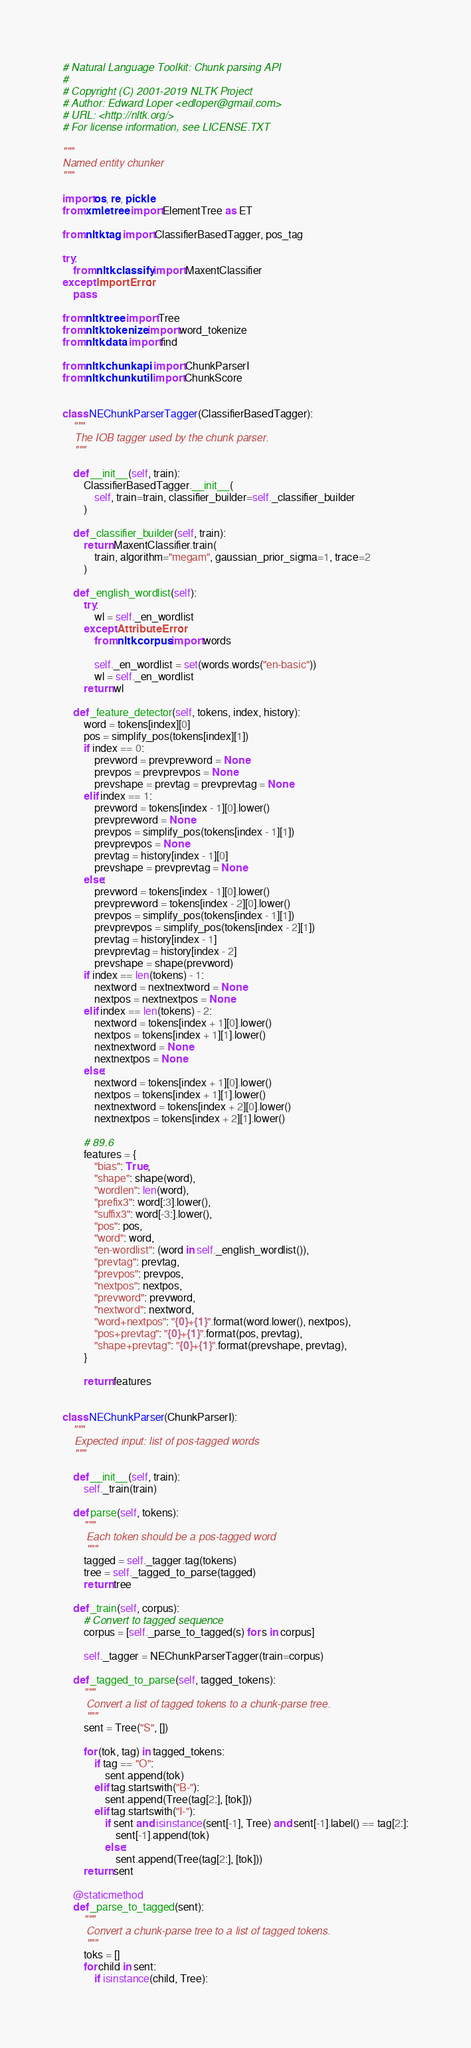<code> <loc_0><loc_0><loc_500><loc_500><_Python_># Natural Language Toolkit: Chunk parsing API
#
# Copyright (C) 2001-2019 NLTK Project
# Author: Edward Loper <edloper@gmail.com>
# URL: <http://nltk.org/>
# For license information, see LICENSE.TXT

"""
Named entity chunker
"""

import os, re, pickle
from xml.etree import ElementTree as ET

from nltk.tag import ClassifierBasedTagger, pos_tag

try:
    from nltk.classify import MaxentClassifier
except ImportError:
    pass

from nltk.tree import Tree
from nltk.tokenize import word_tokenize
from nltk.data import find

from nltk.chunk.api import ChunkParserI
from nltk.chunk.util import ChunkScore


class NEChunkParserTagger(ClassifierBasedTagger):
    """
    The IOB tagger used by the chunk parser.
    """

    def __init__(self, train):
        ClassifierBasedTagger.__init__(
            self, train=train, classifier_builder=self._classifier_builder
        )

    def _classifier_builder(self, train):
        return MaxentClassifier.train(
            train, algorithm="megam", gaussian_prior_sigma=1, trace=2
        )

    def _english_wordlist(self):
        try:
            wl = self._en_wordlist
        except AttributeError:
            from nltk.corpus import words

            self._en_wordlist = set(words.words("en-basic"))
            wl = self._en_wordlist
        return wl

    def _feature_detector(self, tokens, index, history):
        word = tokens[index][0]
        pos = simplify_pos(tokens[index][1])
        if index == 0:
            prevword = prevprevword = None
            prevpos = prevprevpos = None
            prevshape = prevtag = prevprevtag = None
        elif index == 1:
            prevword = tokens[index - 1][0].lower()
            prevprevword = None
            prevpos = simplify_pos(tokens[index - 1][1])
            prevprevpos = None
            prevtag = history[index - 1][0]
            prevshape = prevprevtag = None
        else:
            prevword = tokens[index - 1][0].lower()
            prevprevword = tokens[index - 2][0].lower()
            prevpos = simplify_pos(tokens[index - 1][1])
            prevprevpos = simplify_pos(tokens[index - 2][1])
            prevtag = history[index - 1]
            prevprevtag = history[index - 2]
            prevshape = shape(prevword)
        if index == len(tokens) - 1:
            nextword = nextnextword = None
            nextpos = nextnextpos = None
        elif index == len(tokens) - 2:
            nextword = tokens[index + 1][0].lower()
            nextpos = tokens[index + 1][1].lower()
            nextnextword = None
            nextnextpos = None
        else:
            nextword = tokens[index + 1][0].lower()
            nextpos = tokens[index + 1][1].lower()
            nextnextword = tokens[index + 2][0].lower()
            nextnextpos = tokens[index + 2][1].lower()

        # 89.6
        features = {
            "bias": True,
            "shape": shape(word),
            "wordlen": len(word),
            "prefix3": word[:3].lower(),
            "suffix3": word[-3:].lower(),
            "pos": pos,
            "word": word,
            "en-wordlist": (word in self._english_wordlist()),
            "prevtag": prevtag,
            "prevpos": prevpos,
            "nextpos": nextpos,
            "prevword": prevword,
            "nextword": nextword,
            "word+nextpos": "{0}+{1}".format(word.lower(), nextpos),
            "pos+prevtag": "{0}+{1}".format(pos, prevtag),
            "shape+prevtag": "{0}+{1}".format(prevshape, prevtag),
        }

        return features


class NEChunkParser(ChunkParserI):
    """
    Expected input: list of pos-tagged words
    """

    def __init__(self, train):
        self._train(train)

    def parse(self, tokens):
        """
        Each token should be a pos-tagged word
        """
        tagged = self._tagger.tag(tokens)
        tree = self._tagged_to_parse(tagged)
        return tree

    def _train(self, corpus):
        # Convert to tagged sequence
        corpus = [self._parse_to_tagged(s) for s in corpus]

        self._tagger = NEChunkParserTagger(train=corpus)

    def _tagged_to_parse(self, tagged_tokens):
        """
        Convert a list of tagged tokens to a chunk-parse tree.
        """
        sent = Tree("S", [])

        for (tok, tag) in tagged_tokens:
            if tag == "O":
                sent.append(tok)
            elif tag.startswith("B-"):
                sent.append(Tree(tag[2:], [tok]))
            elif tag.startswith("I-"):
                if sent and isinstance(sent[-1], Tree) and sent[-1].label() == tag[2:]:
                    sent[-1].append(tok)
                else:
                    sent.append(Tree(tag[2:], [tok]))
        return sent

    @staticmethod
    def _parse_to_tagged(sent):
        """
        Convert a chunk-parse tree to a list of tagged tokens.
        """
        toks = []
        for child in sent:
            if isinstance(child, Tree):</code> 